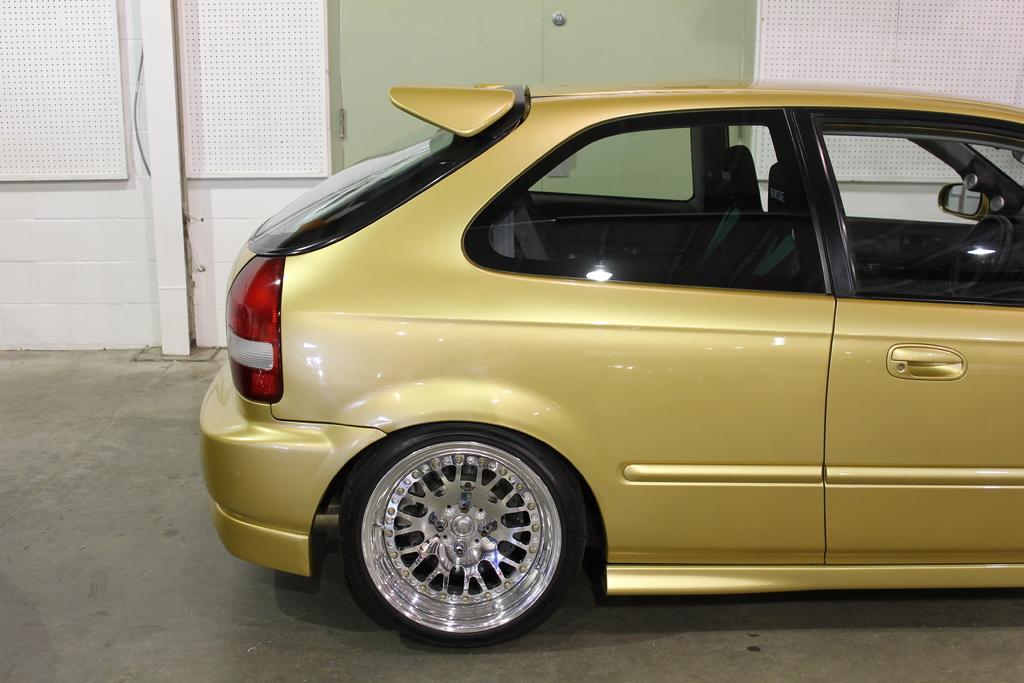Can you describe this image briefly? In this picture, there is a car towards the right. It is in yellow in color. Behind it, there is a door to a wall. 